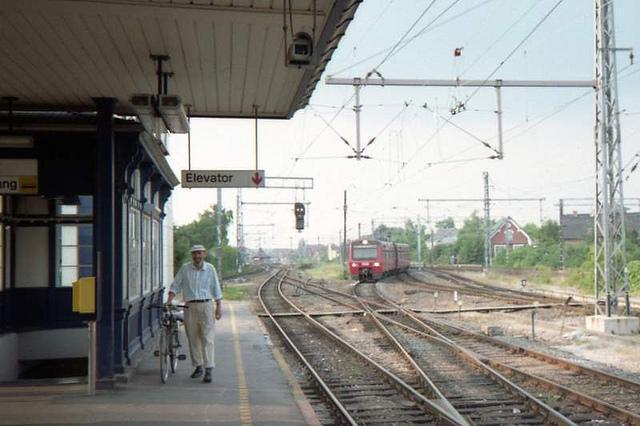How many tracks are here?
Give a very brief answer. 5. How many people are visible?
Give a very brief answer. 1. How many fences shown in this picture are between the giraffe and the camera?
Give a very brief answer. 0. 